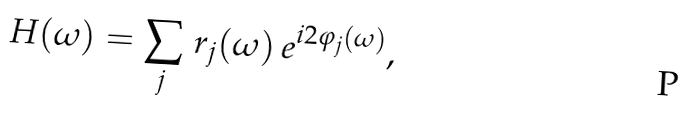<formula> <loc_0><loc_0><loc_500><loc_500>H ( \omega ) = \sum _ { j } \, r _ { j } ( \omega ) \, e ^ { i 2 \varphi _ { j } ( \omega ) } ,</formula> 